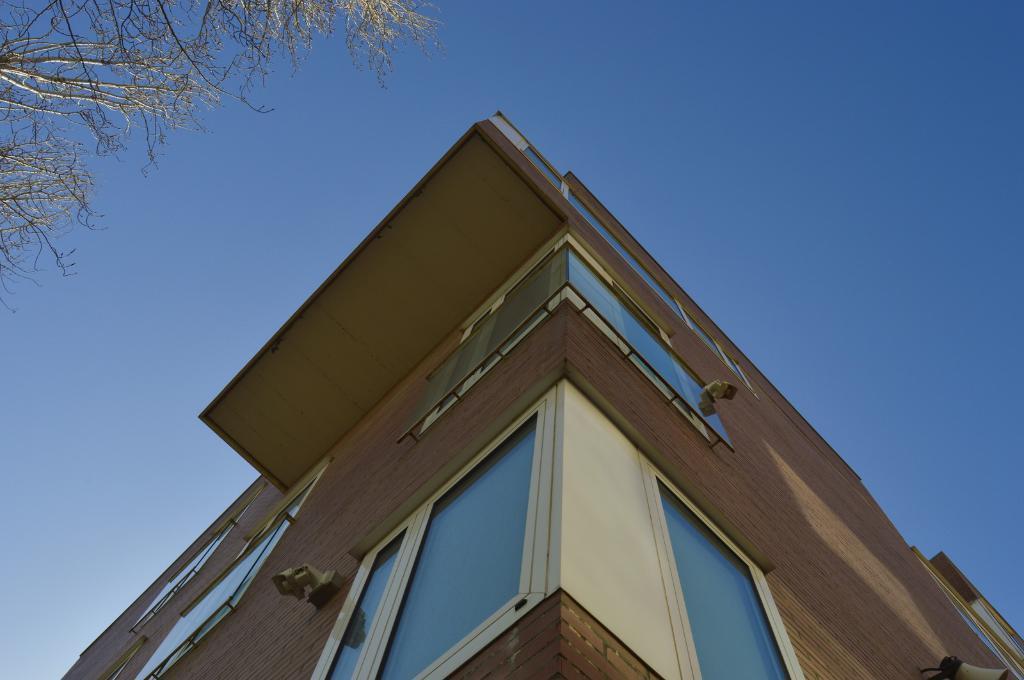Could you give a brief overview of what you see in this image? In this image I can see a building. In the background, I can see a tree and the sky. 